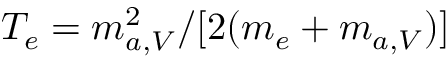<formula> <loc_0><loc_0><loc_500><loc_500>T _ { e } = m _ { a , V } ^ { 2 } / [ 2 ( m _ { e } + m _ { a , V } ) ]</formula> 